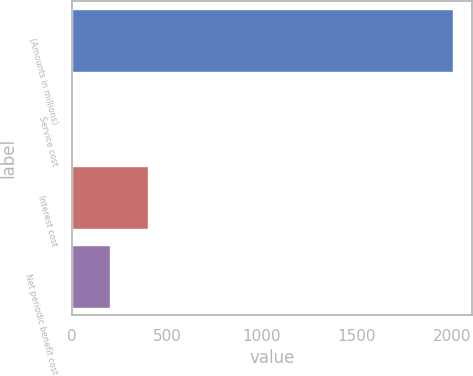Convert chart. <chart><loc_0><loc_0><loc_500><loc_500><bar_chart><fcel>(Amounts in millions)<fcel>Service cost<fcel>Interest cost<fcel>Net periodic benefit cost<nl><fcel>2006<fcel>0.5<fcel>401.6<fcel>201.05<nl></chart> 